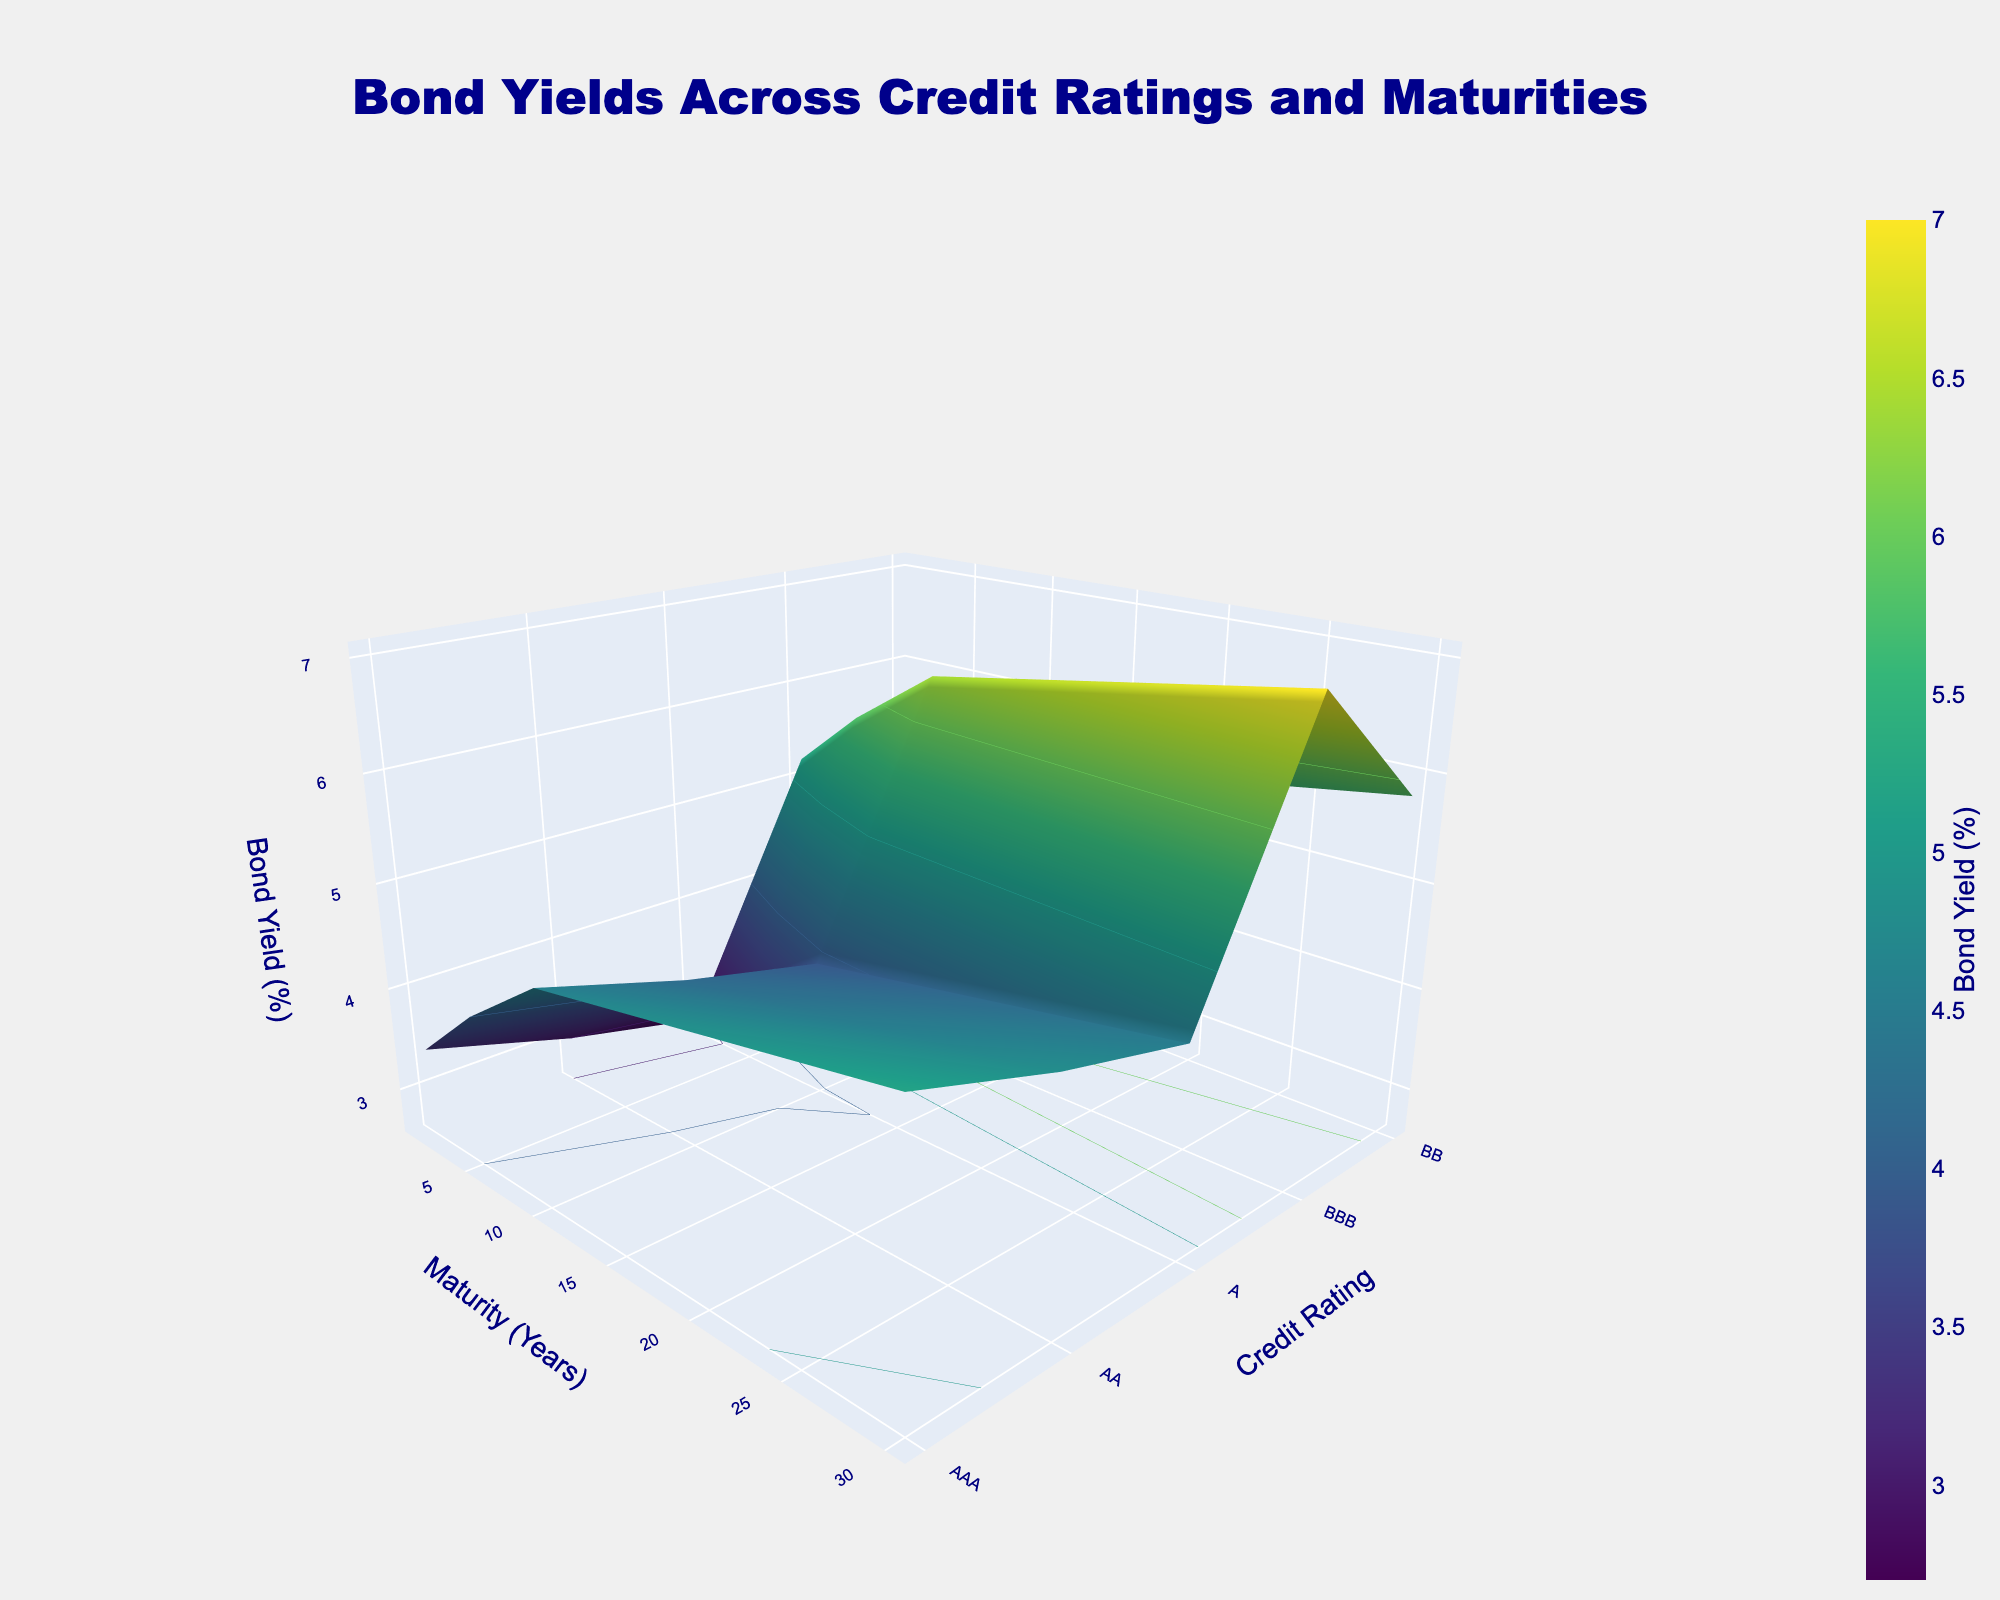What is the title of the figure? The title is located at the top of the figure and typically gives an overview of the data being represented. Here, the title is clearly shown.
Answer: Bond Yields Across Credit Ratings and Maturities What do the x-axis and y-axis represent? The axes are labeled in the figure. The x-axis represents Maturity (Years), and the y-axis represents Credit Rating.
Answer: Maturity (Years) and Credit Rating Which credit rating has the lowest bond yield for a maturity of 5 years? By examining the surface plot for a maturity of 5 years, the lowest bond yield point corresponds to the highest credit rating, which is AAA.
Answer: AAA At a maturity of 10 years, which credit rating shows the highest bond yield? Looking at the surface plot where the x-axis (Maturity) is at 10 years, the highest point on the z-axis (Bond Yield) corresponds to the lowest credit rating, which is BB.
Answer: BB Is there a general trend observed in bond yields as the credit rating decreases? By inspecting how bond yields change along the y-axis from AAA to BB, we can see that bond yields generally increase as credit rating decreases.
Answer: Bond yields increase As maturity increases from 1 to 30 years, what trend do you observe in bond yields for AA credit rating? Following the AA credit rating line from 1 to 30 years on the x-axis, bond yields increase continuously.
Answer: Bond yields increase Compare the bond yield for AAA and A credit ratings at a maturity of 5 years. Locate the points on the surface plot for AAA and A credit ratings at a maturity of 5 years. The bond yields are 3.3% for AAA and 4.0% for A. Thus, A has a higher yield.
Answer: A has higher yield What is the difference in bond yield between BBB and BB credit ratings at a maturity of 30 years? Identify the bond yields for BBB and BB credit ratings at 30 years maturity on the surface plot. The bond yields are 5.8% for BBB and 7.0% for BB. The difference is 7.0% - 5.8% = 1.2%.
Answer: 1.2% How does the bond yield for a BB credit rating with a maturity of 1 year compare to that of an AA credit rating with a maturity of 30 years? Look at the surface plot points for BB at 1 year and AA at 30 years. The bond yields are 5.2% for BB (1 year) and 4.8% for AA (30 years). BB (1 year) has a higher yield.
Answer: BB (1 year) has a higher yield 